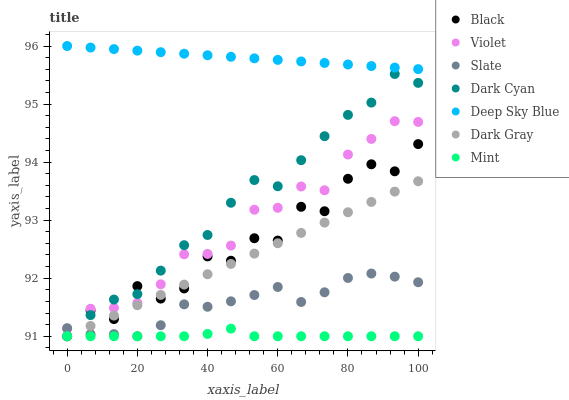Does Mint have the minimum area under the curve?
Answer yes or no. Yes. Does Deep Sky Blue have the maximum area under the curve?
Answer yes or no. Yes. Does Dark Gray have the minimum area under the curve?
Answer yes or no. No. Does Dark Gray have the maximum area under the curve?
Answer yes or no. No. Is Deep Sky Blue the smoothest?
Answer yes or no. Yes. Is Black the roughest?
Answer yes or no. Yes. Is Dark Gray the smoothest?
Answer yes or no. No. Is Dark Gray the roughest?
Answer yes or no. No. Does Slate have the lowest value?
Answer yes or no. Yes. Does Deep Sky Blue have the lowest value?
Answer yes or no. No. Does Deep Sky Blue have the highest value?
Answer yes or no. Yes. Does Dark Gray have the highest value?
Answer yes or no. No. Is Dark Cyan less than Deep Sky Blue?
Answer yes or no. Yes. Is Deep Sky Blue greater than Black?
Answer yes or no. Yes. Does Violet intersect Dark Cyan?
Answer yes or no. Yes. Is Violet less than Dark Cyan?
Answer yes or no. No. Is Violet greater than Dark Cyan?
Answer yes or no. No. Does Dark Cyan intersect Deep Sky Blue?
Answer yes or no. No. 